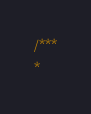Convert code to text. <code><loc_0><loc_0><loc_500><loc_500><_C++_>/***
*</code> 